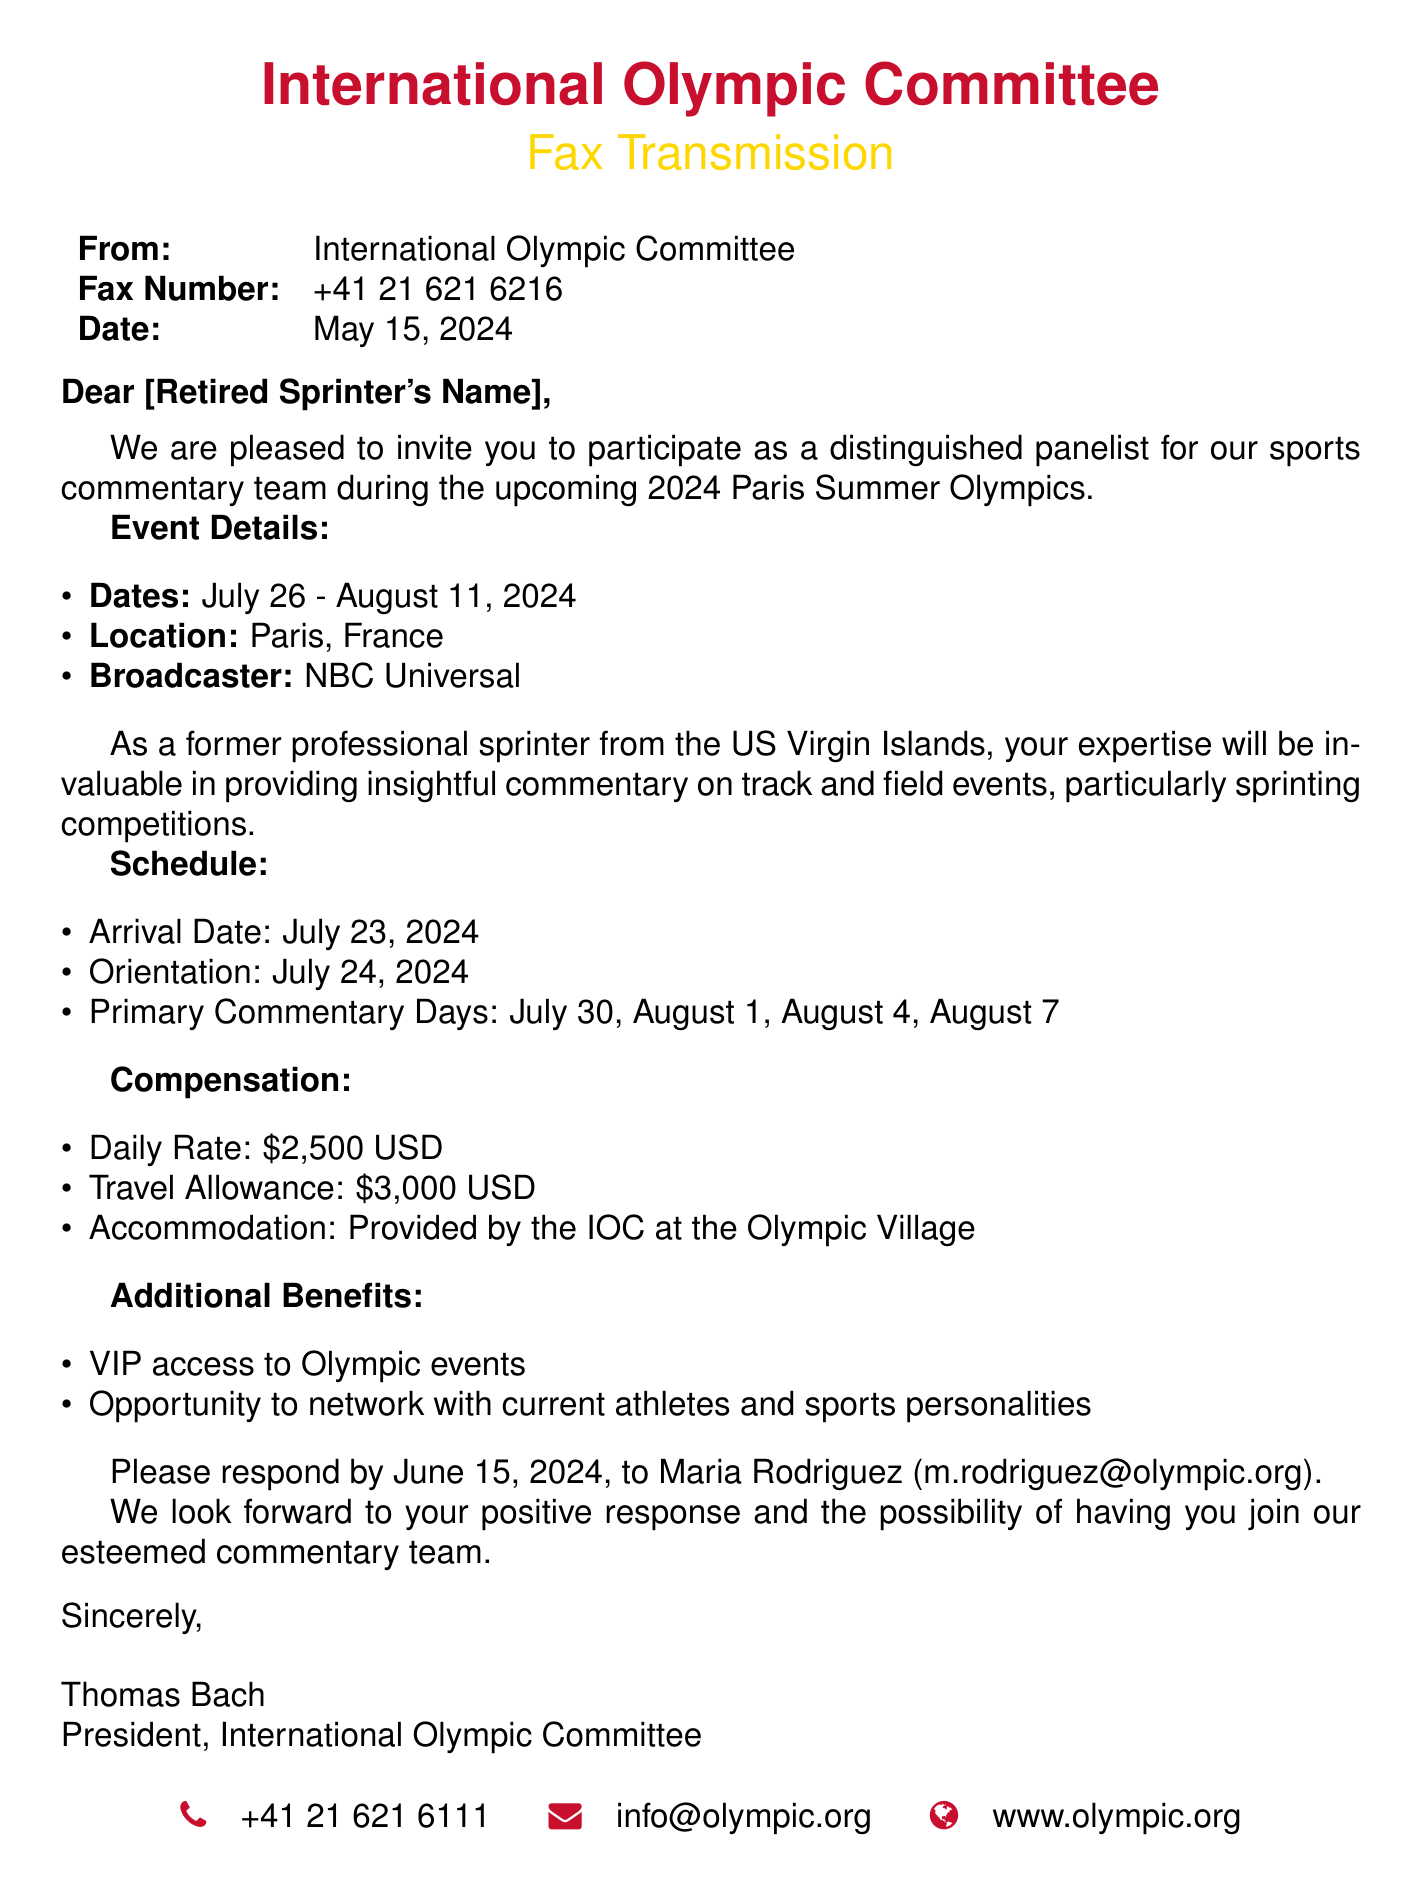What are the dates of the event? The event dates are listed in the document, which are July 26 - August 11, 2024.
Answer: July 26 - August 11, 2024 What is the daily rate for participation? The compensation section mentions the daily rate for participation is $2,500 USD.
Answer: $2,500 USD Who is the broadcaster for the events? The document states that NBC Universal is the broadcaster for the event.
Answer: NBC Universal When is the arrival date? The schedule in the document indicates that the arrival date is July 23, 2024.
Answer: July 23, 2024 What is the travel allowance amount? The travel allowance listed in the compensation section is $3,000 USD.
Answer: $3,000 USD Who should the response be sent to? The document specifies that the response should be sent to Maria Rodriguez.
Answer: Maria Rodriguez On which date is the orientation scheduled? The schedule outlines that orientation is on July 24, 2024.
Answer: July 24, 2024 What is provided for accommodation? The compensation section indicates that accommodation is provided by the IOC at the Olympic Village.
Answer: Provided by the IOC at the Olympic Village What is the contact phone number for the IOC? The document includes contact information which lists the phone number as +41 21 621 6111.
Answer: +41 21 621 6111 What is the location of the event? The document states that the event will take place in Paris, France.
Answer: Paris, France 